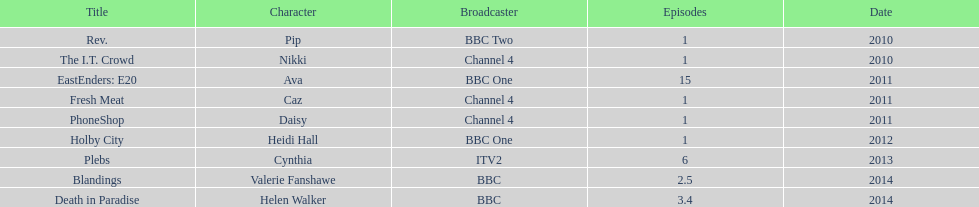How many titles have at least 5 episodes? 2. 